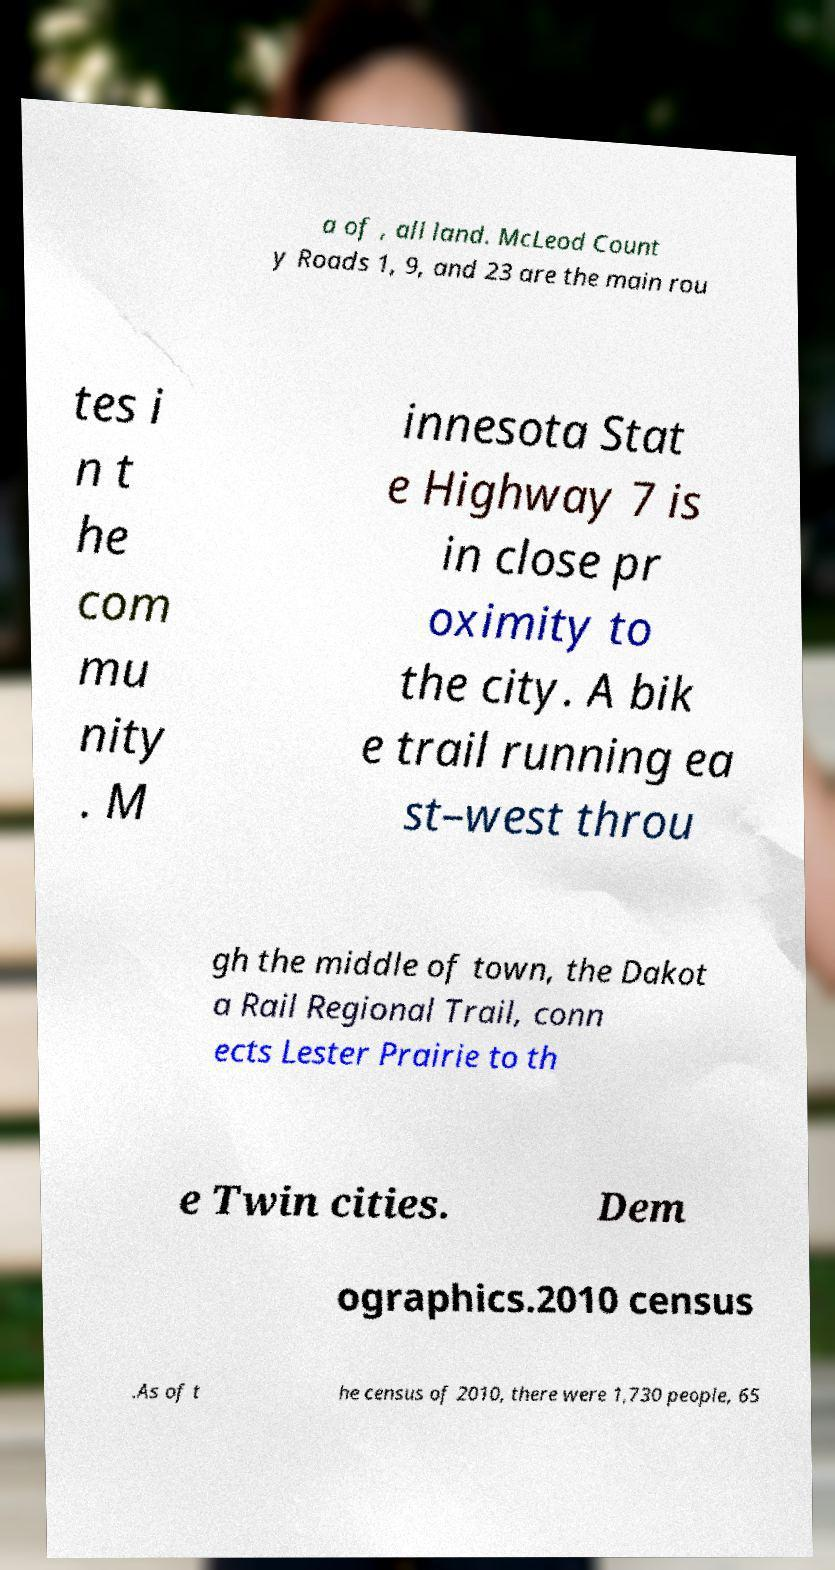What messages or text are displayed in this image? I need them in a readable, typed format. a of , all land. McLeod Count y Roads 1, 9, and 23 are the main rou tes i n t he com mu nity . M innesota Stat e Highway 7 is in close pr oximity to the city. A bik e trail running ea st–west throu gh the middle of town, the Dakot a Rail Regional Trail, conn ects Lester Prairie to th e Twin cities. Dem ographics.2010 census .As of t he census of 2010, there were 1,730 people, 65 